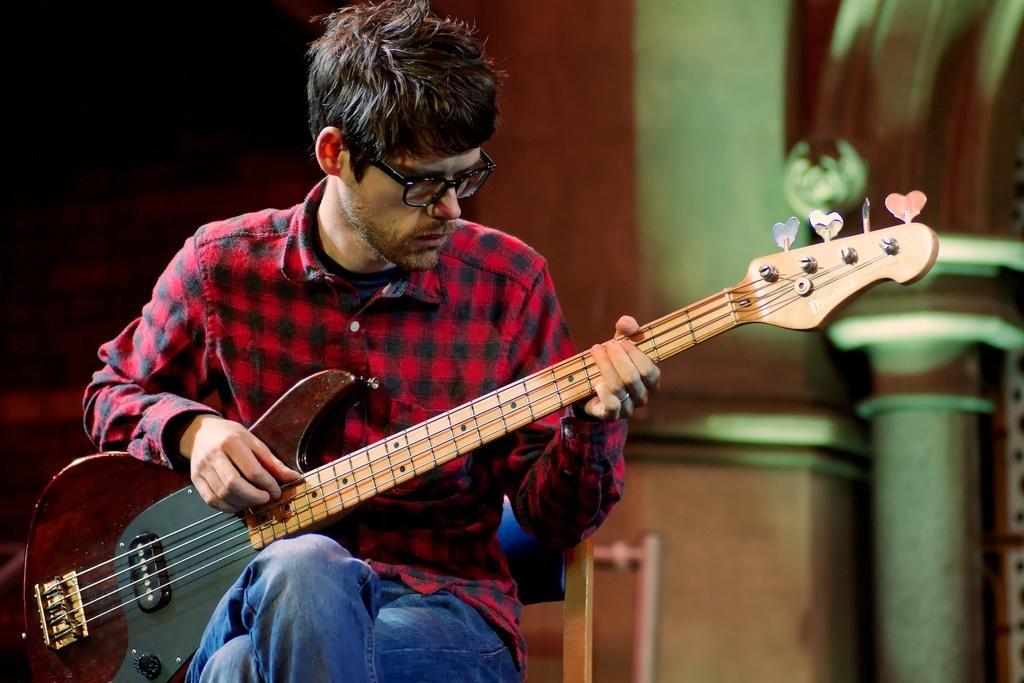Describe this image in one or two sentences. This picture shows that a man is holding the guitar, and playing the guitar with his right hand. He is wearing a red color shirt and he has spectacles. He is sitting on the chair. 